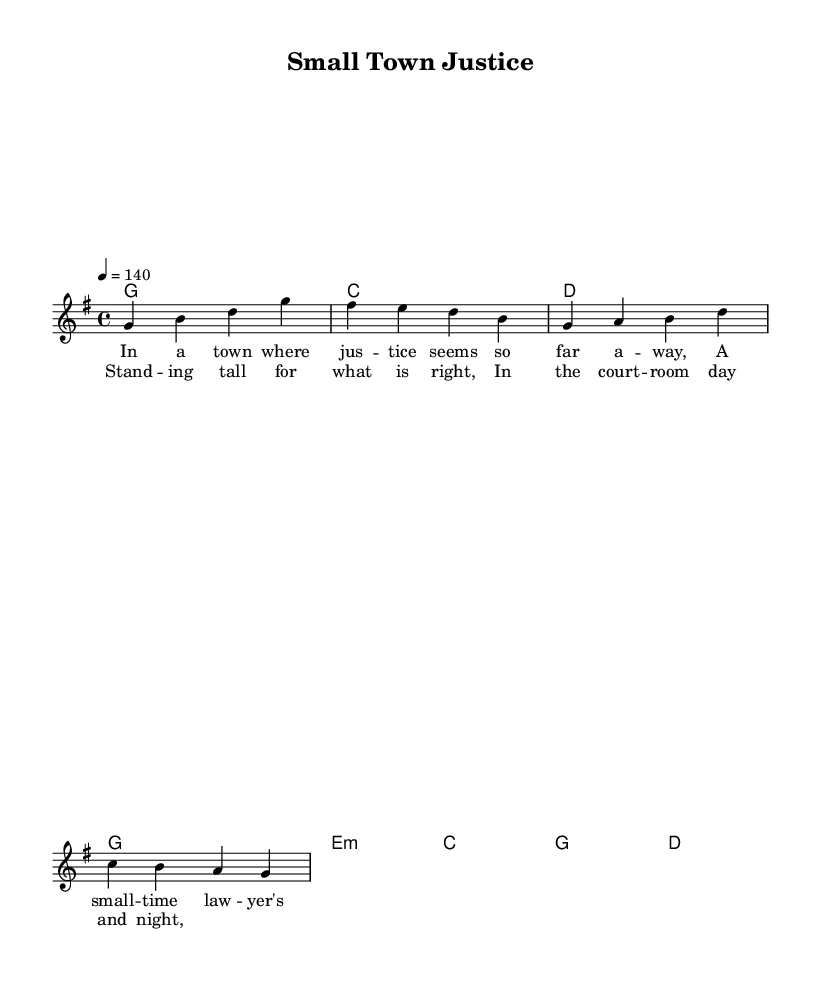What is the key signature of this music? The key signature of the music is G major, which has one sharp (F#). It can be identified by looking at the beginning of the staff, where the sharp is placed.
Answer: G major What is the time signature of this music? The time signature is 4/4, which is indicated by the numbers written at the beginning of the staff. It shows that there are four beats in each measure and a quarter note receives one beat.
Answer: 4/4 What is the tempo marking of this piece? The tempo marking is 140 beats per minute (BPM), indicated by "4 = 140" at the beginning of the score. This specifies the speed at which the piece should be played.
Answer: 140 How many measures are in the melody? The melody consists of four measures, as seen in the section containing the melody notes with vertical bar lines separating each measure.
Answer: Four What is the main theme of the lyrics? The main theme of the lyrics revolves around a small-town lawyer fighting for justice. The text explicitly expresses situations related to a lawyer's struggles and dedication to doing what is right.
Answer: Justice Which chord is used at the beginning of the song? The chord used at the beginning of the song is G major. This is indicated at the very start of the harmonies section, where the chord symbols directly correspond to the melody.
Answer: G major How many times is the word "standing" used in the chorus? The word "standing" is used once in the chorus, as the lyrics clearly indicate it occurs only a single time in that part of the song.
Answer: Once 